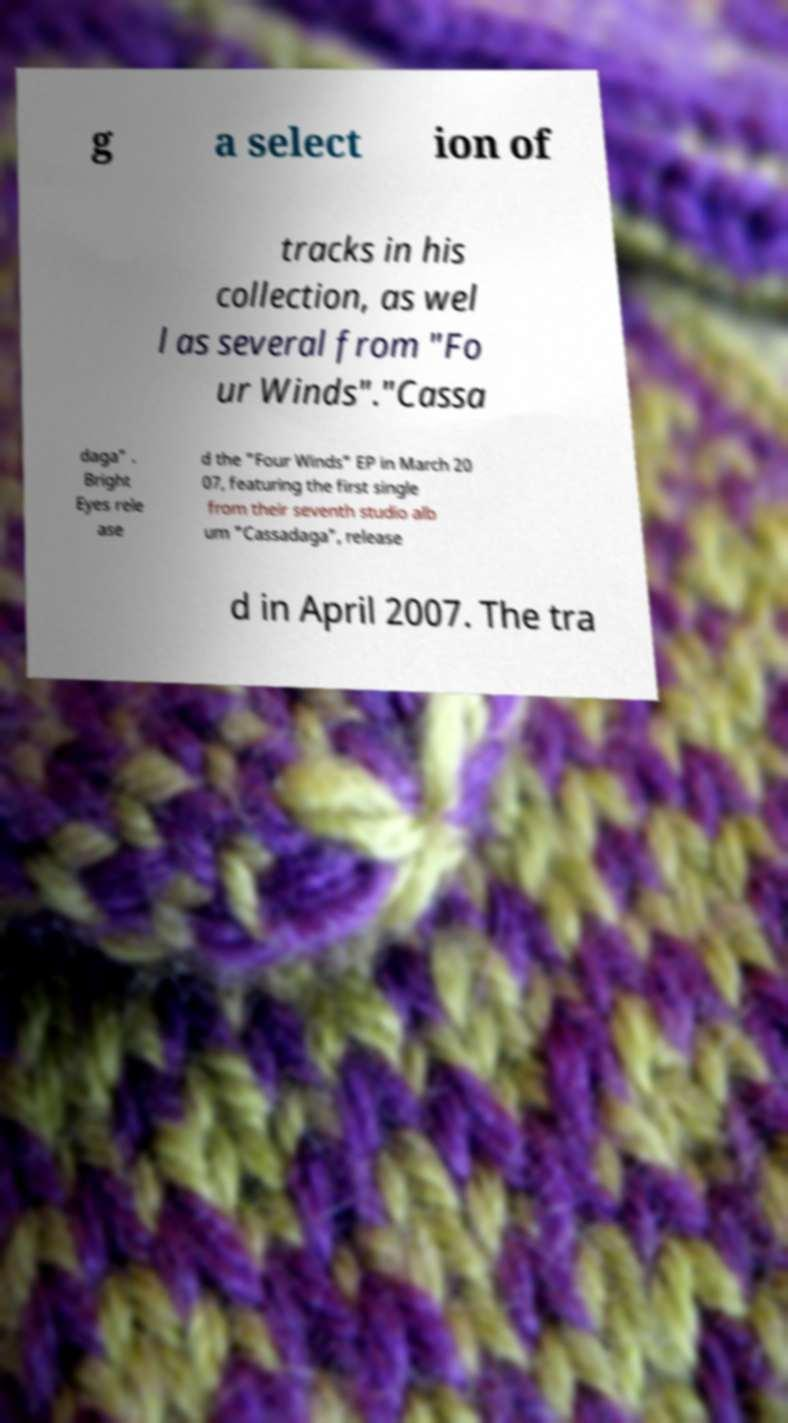Can you accurately transcribe the text from the provided image for me? g a select ion of tracks in his collection, as wel l as several from "Fo ur Winds"."Cassa daga" . Bright Eyes rele ase d the "Four Winds" EP in March 20 07, featuring the first single from their seventh studio alb um "Cassadaga", release d in April 2007. The tra 